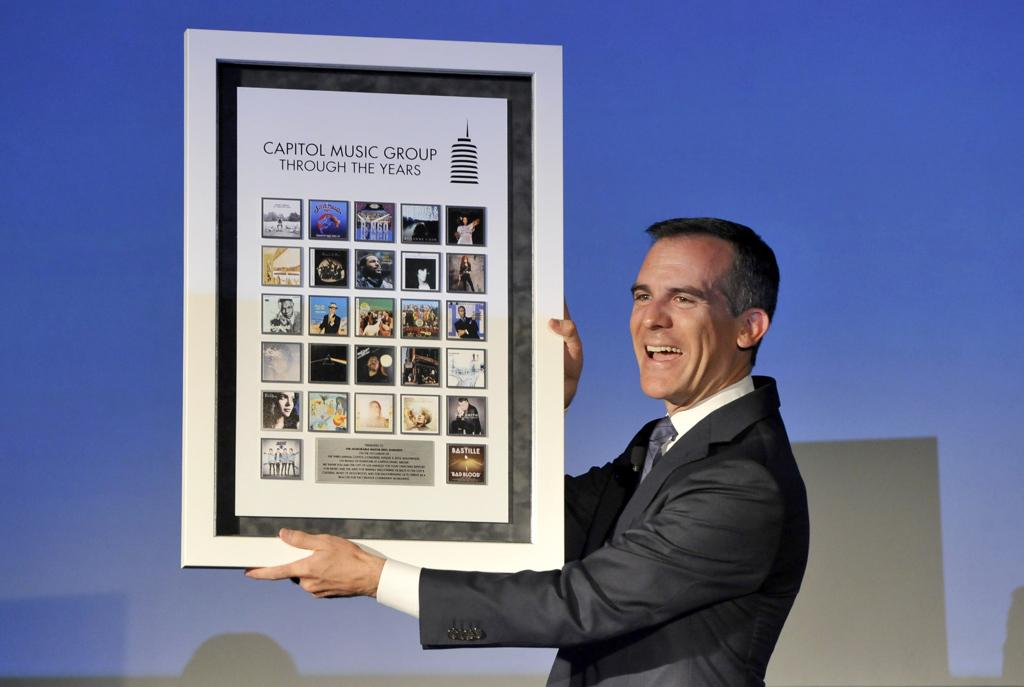<image>
Share a concise interpretation of the image provided. man wearing a suit holds up poster showing capital music group through the years 